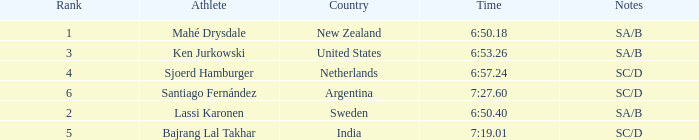What is the highest rank for the team that raced a time of 6:50.40? 2.0. 